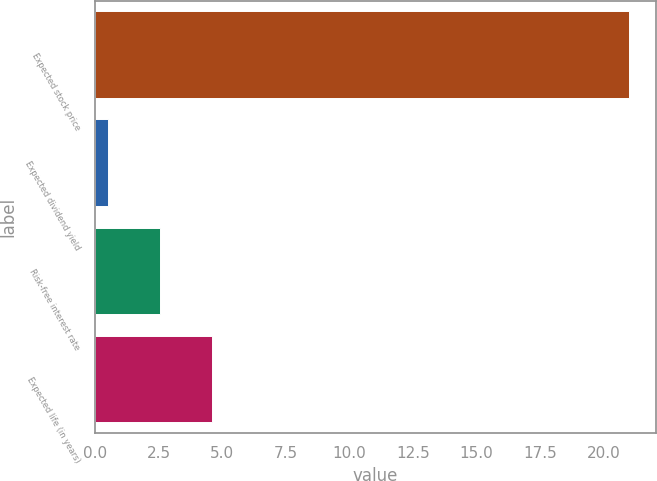Convert chart to OTSL. <chart><loc_0><loc_0><loc_500><loc_500><bar_chart><fcel>Expected stock price<fcel>Expected dividend yield<fcel>Risk-free interest rate<fcel>Expected life (in years)<nl><fcel>21<fcel>0.5<fcel>2.55<fcel>4.6<nl></chart> 